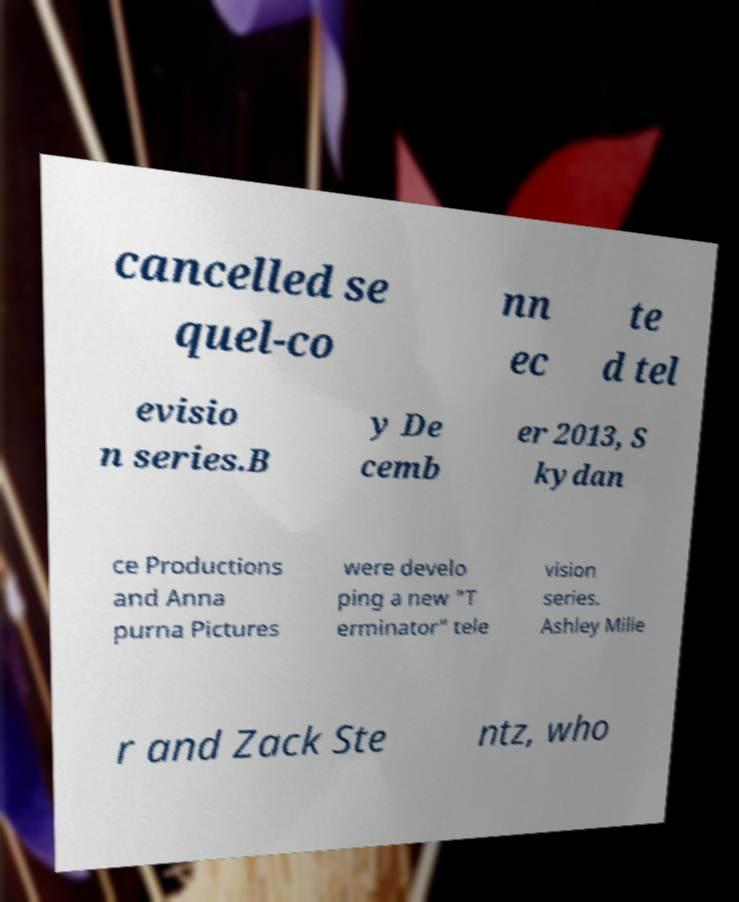Could you assist in decoding the text presented in this image and type it out clearly? cancelled se quel-co nn ec te d tel evisio n series.B y De cemb er 2013, S kydan ce Productions and Anna purna Pictures were develo ping a new "T erminator" tele vision series. Ashley Mille r and Zack Ste ntz, who 